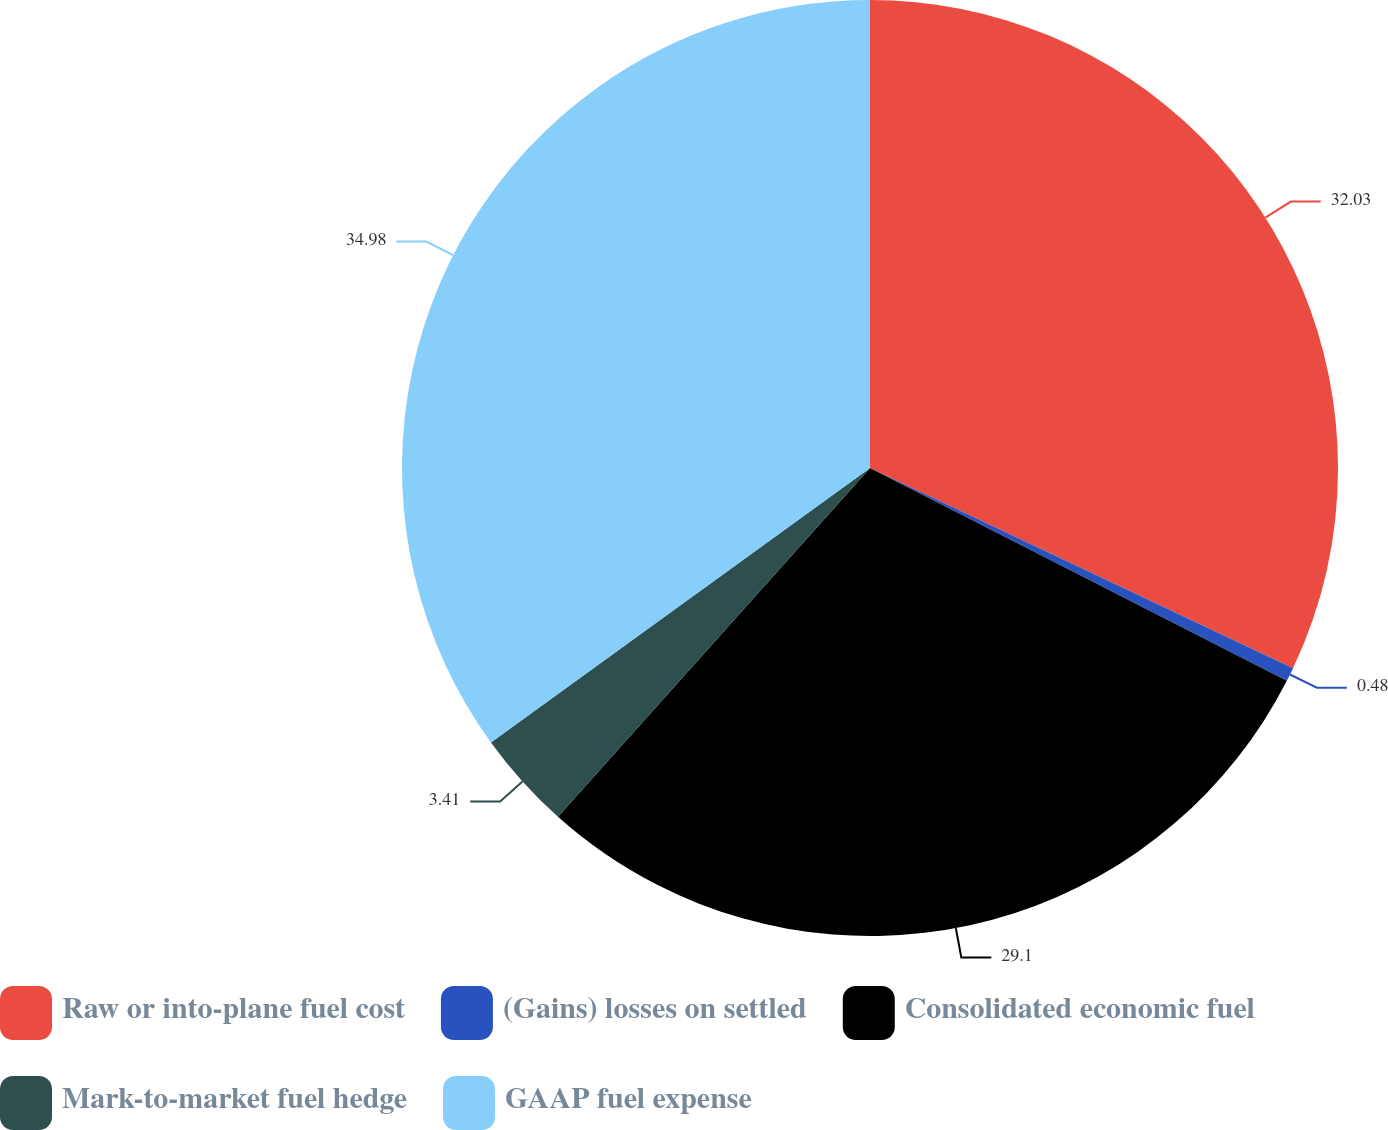<chart> <loc_0><loc_0><loc_500><loc_500><pie_chart><fcel>Raw or into-plane fuel cost<fcel>(Gains) losses on settled<fcel>Consolidated economic fuel<fcel>Mark-to-market fuel hedge<fcel>GAAP fuel expense<nl><fcel>32.03%<fcel>0.48%<fcel>29.1%<fcel>3.41%<fcel>34.97%<nl></chart> 